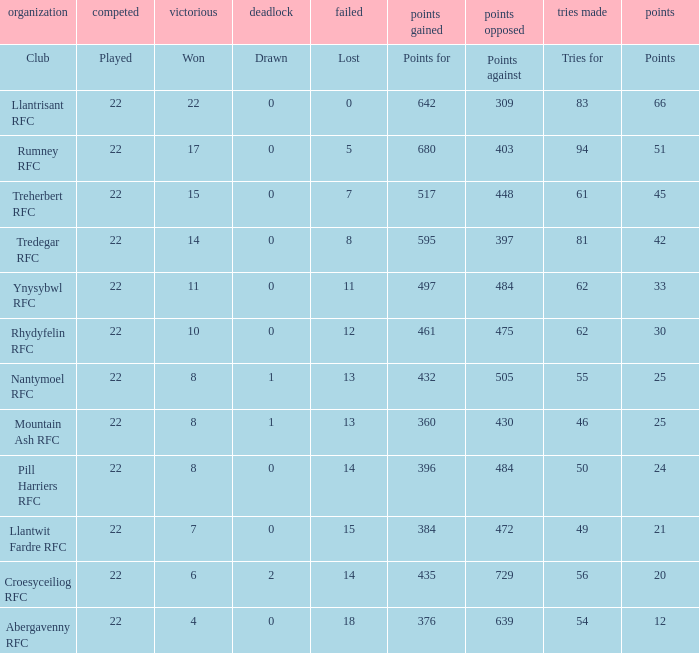Parse the table in full. {'header': ['organization', 'competed', 'victorious', 'deadlock', 'failed', 'points gained', 'points opposed', 'tries made', 'points'], 'rows': [['Club', 'Played', 'Won', 'Drawn', 'Lost', 'Points for', 'Points against', 'Tries for', 'Points'], ['Llantrisant RFC', '22', '22', '0', '0', '642', '309', '83', '66'], ['Rumney RFC', '22', '17', '0', '5', '680', '403', '94', '51'], ['Treherbert RFC', '22', '15', '0', '7', '517', '448', '61', '45'], ['Tredegar RFC', '22', '14', '0', '8', '595', '397', '81', '42'], ['Ynysybwl RFC', '22', '11', '0', '11', '497', '484', '62', '33'], ['Rhydyfelin RFC', '22', '10', '0', '12', '461', '475', '62', '30'], ['Nantymoel RFC', '22', '8', '1', '13', '432', '505', '55', '25'], ['Mountain Ash RFC', '22', '8', '1', '13', '360', '430', '46', '25'], ['Pill Harriers RFC', '22', '8', '0', '14', '396', '484', '50', '24'], ['Llantwit Fardre RFC', '22', '7', '0', '15', '384', '472', '49', '21'], ['Croesyceiliog RFC', '22', '6', '2', '14', '435', '729', '56', '20'], ['Abergavenny RFC', '22', '4', '0', '18', '376', '639', '54', '12']]} How many tries for were scored by the team that had exactly 396 points for? 50.0. 